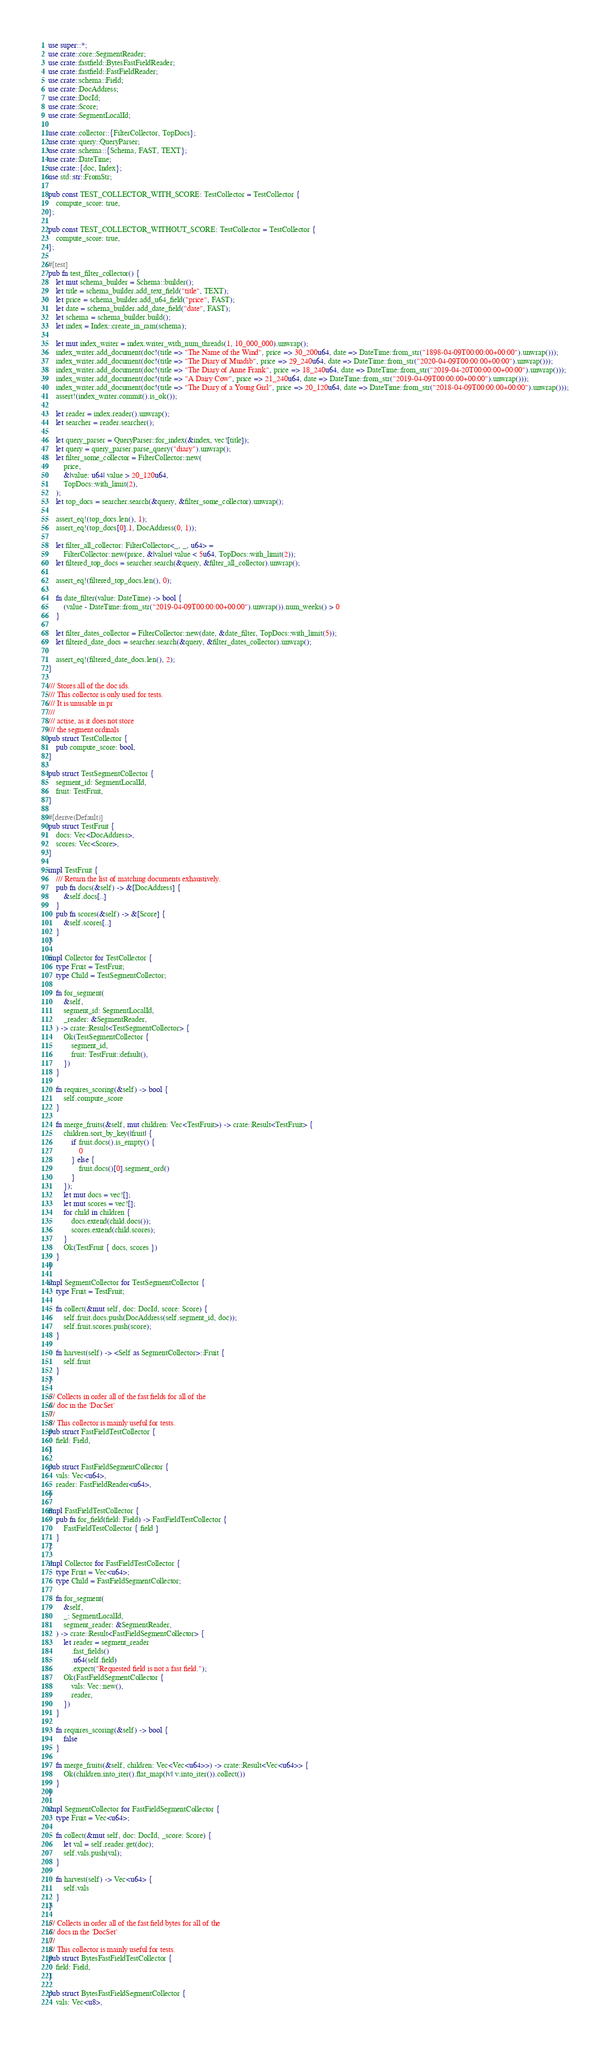<code> <loc_0><loc_0><loc_500><loc_500><_Rust_>use super::*;
use crate::core::SegmentReader;
use crate::fastfield::BytesFastFieldReader;
use crate::fastfield::FastFieldReader;
use crate::schema::Field;
use crate::DocAddress;
use crate::DocId;
use crate::Score;
use crate::SegmentLocalId;

use crate::collector::{FilterCollector, TopDocs};
use crate::query::QueryParser;
use crate::schema::{Schema, FAST, TEXT};
use crate::DateTime;
use crate::{doc, Index};
use std::str::FromStr;

pub const TEST_COLLECTOR_WITH_SCORE: TestCollector = TestCollector {
    compute_score: true,
};

pub const TEST_COLLECTOR_WITHOUT_SCORE: TestCollector = TestCollector {
    compute_score: true,
};

#[test]
pub fn test_filter_collector() {
    let mut schema_builder = Schema::builder();
    let title = schema_builder.add_text_field("title", TEXT);
    let price = schema_builder.add_u64_field("price", FAST);
    let date = schema_builder.add_date_field("date", FAST);
    let schema = schema_builder.build();
    let index = Index::create_in_ram(schema);

    let mut index_writer = index.writer_with_num_threads(1, 10_000_000).unwrap();
    index_writer.add_document(doc!(title => "The Name of the Wind", price => 30_200u64, date => DateTime::from_str("1898-04-09T00:00:00+00:00").unwrap()));
    index_writer.add_document(doc!(title => "The Diary of Muadib", price => 29_240u64, date => DateTime::from_str("2020-04-09T00:00:00+00:00").unwrap()));
    index_writer.add_document(doc!(title => "The Diary of Anne Frank", price => 18_240u64, date => DateTime::from_str("2019-04-20T00:00:00+00:00").unwrap()));
    index_writer.add_document(doc!(title => "A Dairy Cow", price => 21_240u64, date => DateTime::from_str("2019-04-09T00:00:00+00:00").unwrap()));
    index_writer.add_document(doc!(title => "The Diary of a Young Girl", price => 20_120u64, date => DateTime::from_str("2018-04-09T00:00:00+00:00").unwrap()));
    assert!(index_writer.commit().is_ok());

    let reader = index.reader().unwrap();
    let searcher = reader.searcher();

    let query_parser = QueryParser::for_index(&index, vec![title]);
    let query = query_parser.parse_query("diary").unwrap();
    let filter_some_collector = FilterCollector::new(
        price,
        &|value: u64| value > 20_120u64,
        TopDocs::with_limit(2),
    );
    let top_docs = searcher.search(&query, &filter_some_collector).unwrap();

    assert_eq!(top_docs.len(), 1);
    assert_eq!(top_docs[0].1, DocAddress(0, 1));

    let filter_all_collector: FilterCollector<_, _, u64> =
        FilterCollector::new(price, &|value| value < 5u64, TopDocs::with_limit(2));
    let filtered_top_docs = searcher.search(&query, &filter_all_collector).unwrap();

    assert_eq!(filtered_top_docs.len(), 0);

    fn date_filter(value: DateTime) -> bool {
        (value - DateTime::from_str("2019-04-09T00:00:00+00:00").unwrap()).num_weeks() > 0
    }

    let filter_dates_collector = FilterCollector::new(date, &date_filter, TopDocs::with_limit(5));
    let filtered_date_docs = searcher.search(&query, &filter_dates_collector).unwrap();

    assert_eq!(filtered_date_docs.len(), 2);
}

/// Stores all of the doc ids.
/// This collector is only used for tests.
/// It is unusable in pr
///
/// actise, as it does not store
/// the segment ordinals
pub struct TestCollector {
    pub compute_score: bool,
}

pub struct TestSegmentCollector {
    segment_id: SegmentLocalId,
    fruit: TestFruit,
}

#[derive(Default)]
pub struct TestFruit {
    docs: Vec<DocAddress>,
    scores: Vec<Score>,
}

impl TestFruit {
    /// Return the list of matching documents exhaustively.
    pub fn docs(&self) -> &[DocAddress] {
        &self.docs[..]
    }
    pub fn scores(&self) -> &[Score] {
        &self.scores[..]
    }
}

impl Collector for TestCollector {
    type Fruit = TestFruit;
    type Child = TestSegmentCollector;

    fn for_segment(
        &self,
        segment_id: SegmentLocalId,
        _reader: &SegmentReader,
    ) -> crate::Result<TestSegmentCollector> {
        Ok(TestSegmentCollector {
            segment_id,
            fruit: TestFruit::default(),
        })
    }

    fn requires_scoring(&self) -> bool {
        self.compute_score
    }

    fn merge_fruits(&self, mut children: Vec<TestFruit>) -> crate::Result<TestFruit> {
        children.sort_by_key(|fruit| {
            if fruit.docs().is_empty() {
                0
            } else {
                fruit.docs()[0].segment_ord()
            }
        });
        let mut docs = vec![];
        let mut scores = vec![];
        for child in children {
            docs.extend(child.docs());
            scores.extend(child.scores);
        }
        Ok(TestFruit { docs, scores })
    }
}

impl SegmentCollector for TestSegmentCollector {
    type Fruit = TestFruit;

    fn collect(&mut self, doc: DocId, score: Score) {
        self.fruit.docs.push(DocAddress(self.segment_id, doc));
        self.fruit.scores.push(score);
    }

    fn harvest(self) -> <Self as SegmentCollector>::Fruit {
        self.fruit
    }
}

/// Collects in order all of the fast fields for all of the
/// doc in the `DocSet`
///
/// This collector is mainly useful for tests.
pub struct FastFieldTestCollector {
    field: Field,
}

pub struct FastFieldSegmentCollector {
    vals: Vec<u64>,
    reader: FastFieldReader<u64>,
}

impl FastFieldTestCollector {
    pub fn for_field(field: Field) -> FastFieldTestCollector {
        FastFieldTestCollector { field }
    }
}

impl Collector for FastFieldTestCollector {
    type Fruit = Vec<u64>;
    type Child = FastFieldSegmentCollector;

    fn for_segment(
        &self,
        _: SegmentLocalId,
        segment_reader: &SegmentReader,
    ) -> crate::Result<FastFieldSegmentCollector> {
        let reader = segment_reader
            .fast_fields()
            .u64(self.field)
            .expect("Requested field is not a fast field.");
        Ok(FastFieldSegmentCollector {
            vals: Vec::new(),
            reader,
        })
    }

    fn requires_scoring(&self) -> bool {
        false
    }

    fn merge_fruits(&self, children: Vec<Vec<u64>>) -> crate::Result<Vec<u64>> {
        Ok(children.into_iter().flat_map(|v| v.into_iter()).collect())
    }
}

impl SegmentCollector for FastFieldSegmentCollector {
    type Fruit = Vec<u64>;

    fn collect(&mut self, doc: DocId, _score: Score) {
        let val = self.reader.get(doc);
        self.vals.push(val);
    }

    fn harvest(self) -> Vec<u64> {
        self.vals
    }
}

/// Collects in order all of the fast field bytes for all of the
/// docs in the `DocSet`
///
/// This collector is mainly useful for tests.
pub struct BytesFastFieldTestCollector {
    field: Field,
}

pub struct BytesFastFieldSegmentCollector {
    vals: Vec<u8>,</code> 